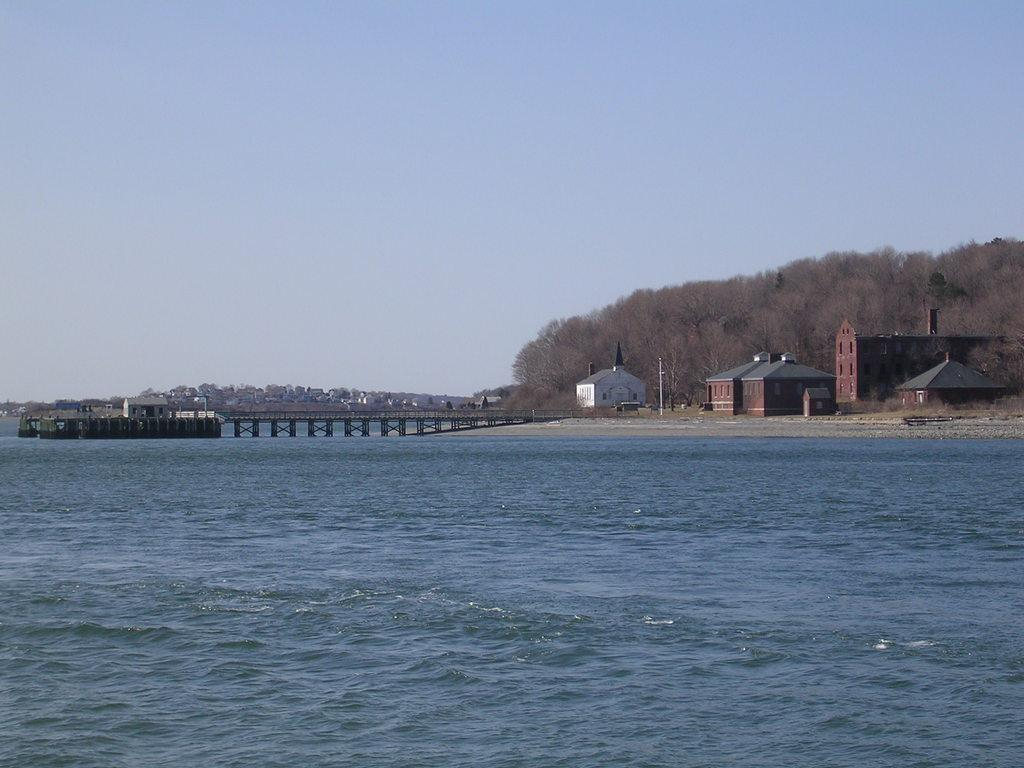What is located in front of the image? There is water in front of the image. What can be seen in the middle of the image? There is a bridge in the middle of the image. What type of structures are present in the image? There are buildings in the image. What other natural elements can be seen in the image? There are trees in the image. What is visible in the background of the image? The sky is visible in the background of the image. What color is the sweater worn by the person standing next to the bag in the image? There are no people or bags present in the image; it features water, a bridge, buildings, trees, and the sky. How many houses can be seen in the image? There are no houses present in the image; it features water, a bridge, buildings, trees, and the sky. 